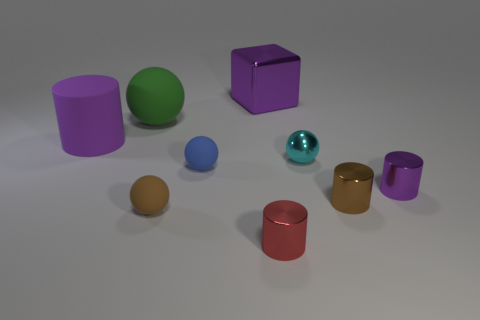Is the big matte cylinder the same color as the big matte ball?
Keep it short and to the point. No. There is another large thing that is the same material as the cyan thing; what is its shape?
Provide a succinct answer. Cube. Are there any big metallic cubes of the same color as the big metallic thing?
Your response must be concise. No. How many matte objects are blue objects or small things?
Make the answer very short. 2. How many tiny shiny cylinders are in front of the large matte object that is behind the big cylinder?
Keep it short and to the point. 3. What number of other tiny red cylinders have the same material as the red cylinder?
Offer a very short reply. 0. What number of big things are either brown metallic cylinders or red metallic cylinders?
Ensure brevity in your answer.  0. What is the shape of the large object that is both left of the blue matte object and right of the large purple matte thing?
Offer a terse response. Sphere. Does the tiny red object have the same material as the big sphere?
Offer a very short reply. No. What color is the metal ball that is the same size as the brown matte object?
Give a very brief answer. Cyan. 